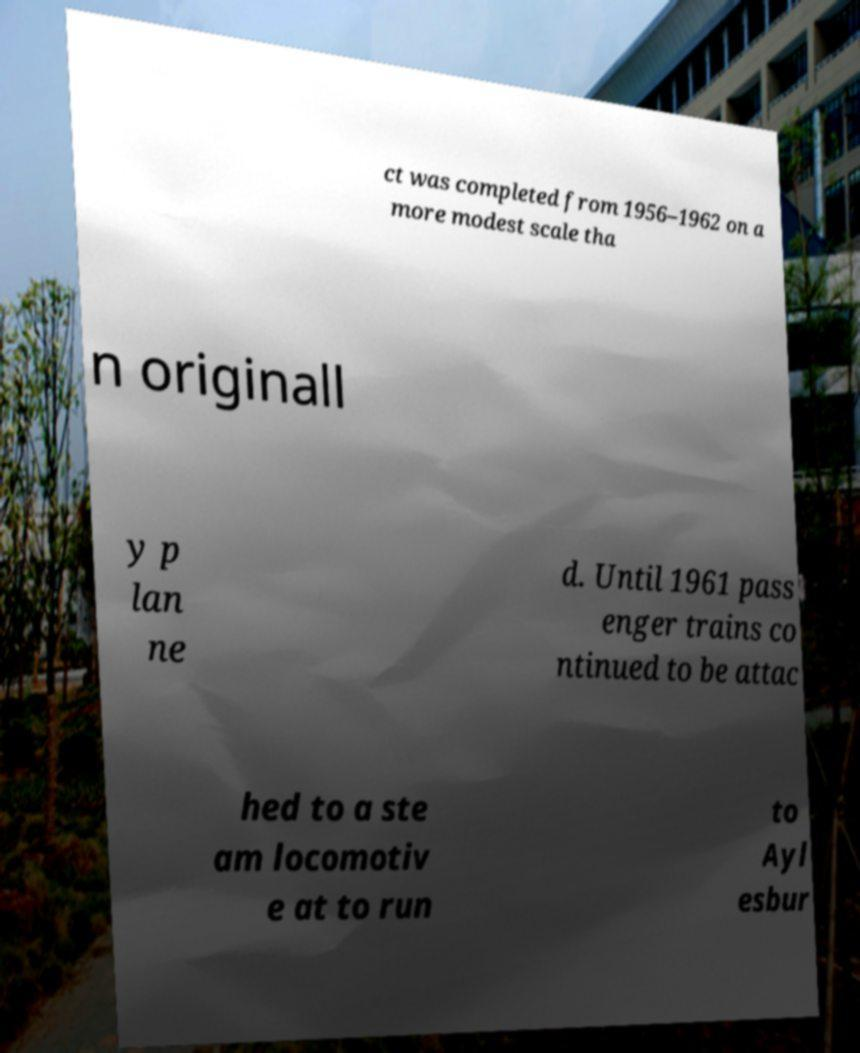There's text embedded in this image that I need extracted. Can you transcribe it verbatim? ct was completed from 1956–1962 on a more modest scale tha n originall y p lan ne d. Until 1961 pass enger trains co ntinued to be attac hed to a ste am locomotiv e at to run to Ayl esbur 